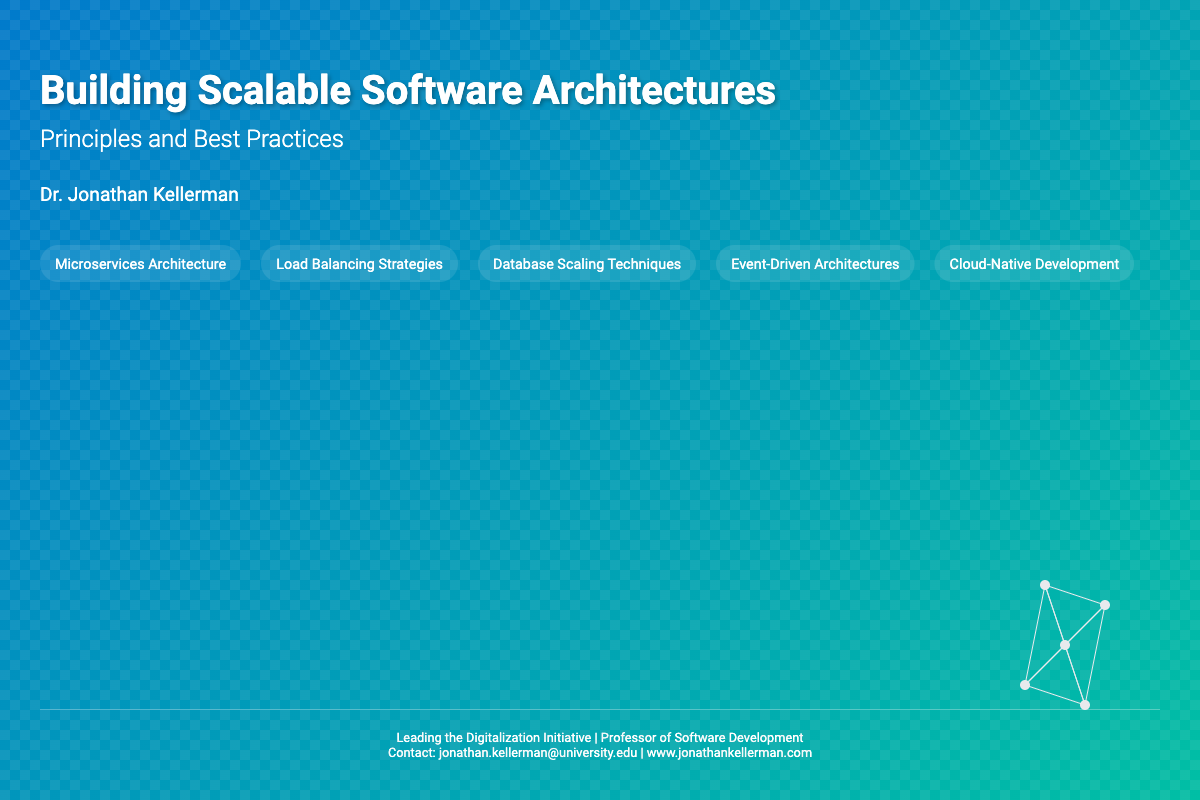What is the title of the book? The title of the book is clearly stated at the top of the cover.
Answer: Building Scalable Software Architectures Who is the author of the book? The author's name is mentioned in the author section of the cover.
Answer: Dr. Jonathan Kellerman How many topics are listed on the cover? The cover includes five specific topics related to software architectures.
Answer: 5 What is one of the topics mentioned on the cover? One topic is highlighted in the topics section.
Answer: Microservices Architecture What is the primary focus of the book? The subtitle indicates the main theme or focus of the book.
Answer: Principles and Best Practices What aesthetic elements are present on the cover? The design includes specific elements that contribute to the overall theme.
Answer: Geometric patterns Where can the author's contact information be found? The author's contact details are provided in the footer section.
Answer: Footer What color gradient is used in the background? The background features a gradient made with two specific colors.
Answer: Blue to teal 